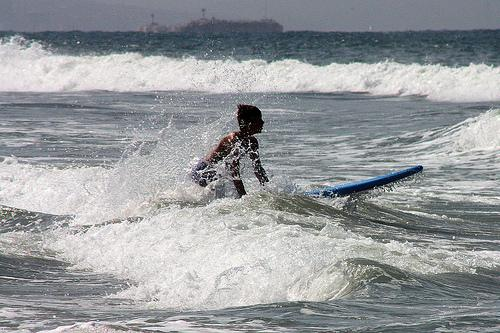If you were to advertise a surfboard using this image, what would you highlight in your advertisement? Experience the thrill of riding the waves with our high-performance blue surfboard designed for speed, stability and style, as demonstrated by this young surfer. Describe how the boy is handling the surfboard in the image. The boy is holding the edges of the blue surfboard, maintaining balance and control as he rides the rolling wave. How would you describe the water in the image and what is its general mood? The water is described as rambunctious, tumultuous, and boisterous, giving the sense of an energetic and lively ocean scene. What is the general expression of the boy while riding the surfboard? Look at his hair for a hint. The boy's hair is blowing in the wind, indicating he is experiencing the thrill and excitement of riding the waves. Identify the main person in the image and describe their attire. A boy with dark hair and tanned skin wearing blue board shorts and a purple swimsuit is the main person in the image. Choose one object from the image and describe its color and position. The white ocean foam from a rolling wave is near the boy on a surfboard and can be seen in the foreground with its vibrant color. Write a short poem inspired by the image. The ocean waves, his playground, his home. What does the scene in the image primarily focus on? The scene focuses on a boy surfing on a blue surfboard in the middle of choppy blue waters with waves. What are the weather conditions in the image, and how can you tell? The weather conditions are clear and sunny with blue skies over the ocean, indicating a bright and pleasant day for surfing. Mention two objects in the background of the image and describe their locations. An island can be seen in the distance at the top-left of the image, while a large freighter appears further out on the water towards the middle of the frame. 